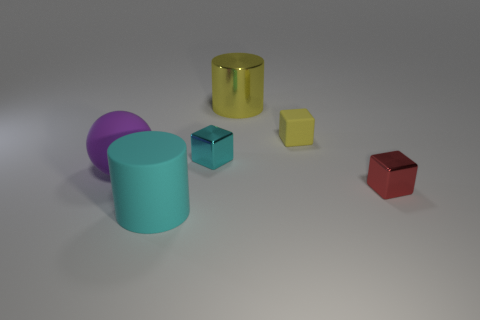Subtract all shiny blocks. How many blocks are left? 1 Add 4 red metal cylinders. How many objects exist? 10 Subtract all yellow cylinders. How many cylinders are left? 1 Subtract all cylinders. How many objects are left? 4 Subtract 2 cubes. How many cubes are left? 1 Subtract all brown balls. Subtract all gray cylinders. How many balls are left? 1 Subtract all cyan cylinders. How many yellow blocks are left? 1 Subtract all cyan metallic objects. Subtract all matte cylinders. How many objects are left? 4 Add 5 purple spheres. How many purple spheres are left? 6 Add 4 shiny things. How many shiny things exist? 7 